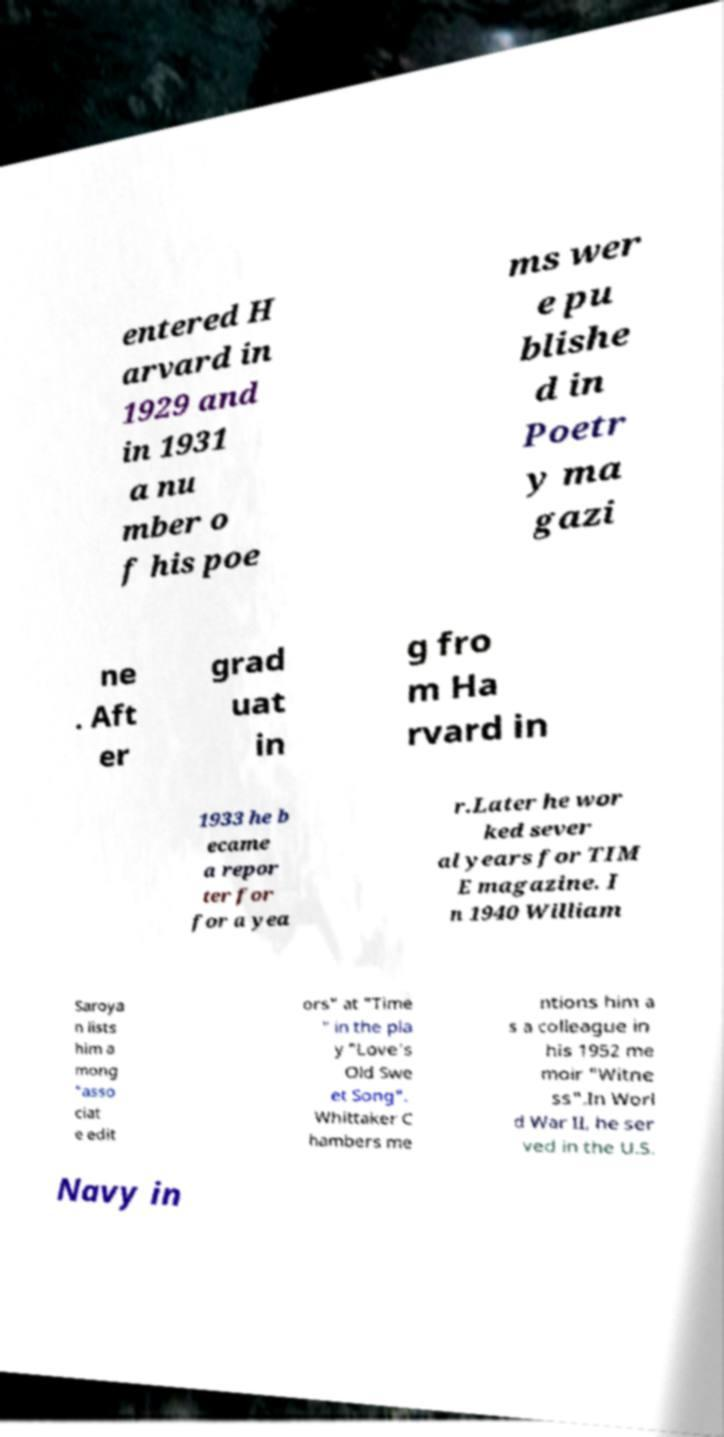Please read and relay the text visible in this image. What does it say? entered H arvard in 1929 and in 1931 a nu mber o f his poe ms wer e pu blishe d in Poetr y ma gazi ne . Aft er grad uat in g fro m Ha rvard in 1933 he b ecame a repor ter for for a yea r.Later he wor ked sever al years for TIM E magazine. I n 1940 William Saroya n lists him a mong "asso ciat e edit ors" at "Time " in the pla y "Love's Old Swe et Song". Whittaker C hambers me ntions him a s a colleague in his 1952 me moir "Witne ss".In Worl d War II, he ser ved in the U.S. Navy in 